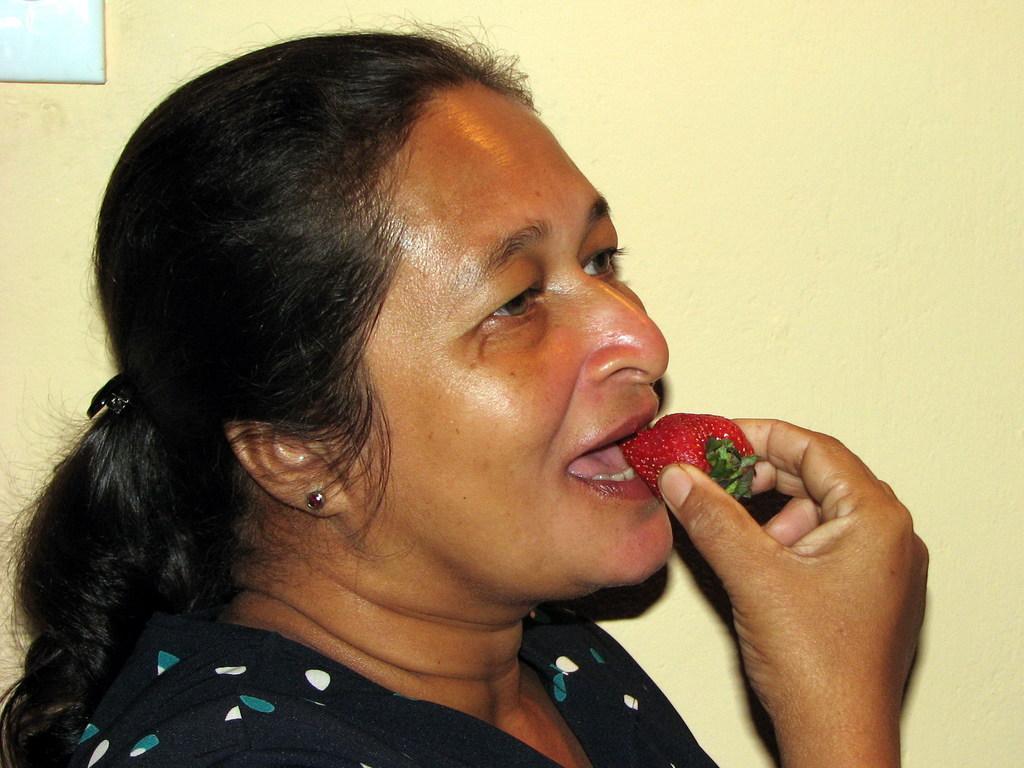Please provide a concise description of this image. In the center of the image there is a woman eating strawberry. In the background there is wall. 